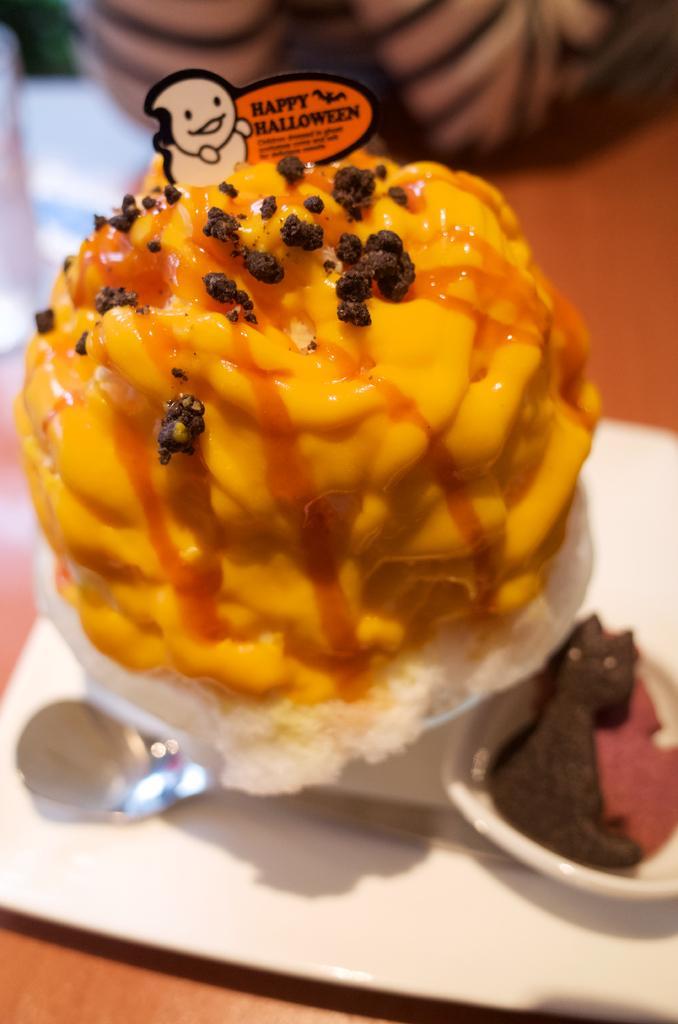Can you describe this image briefly? In this image there is a table, on that table there are ice creams and a spoon, in the background it is blurred. 